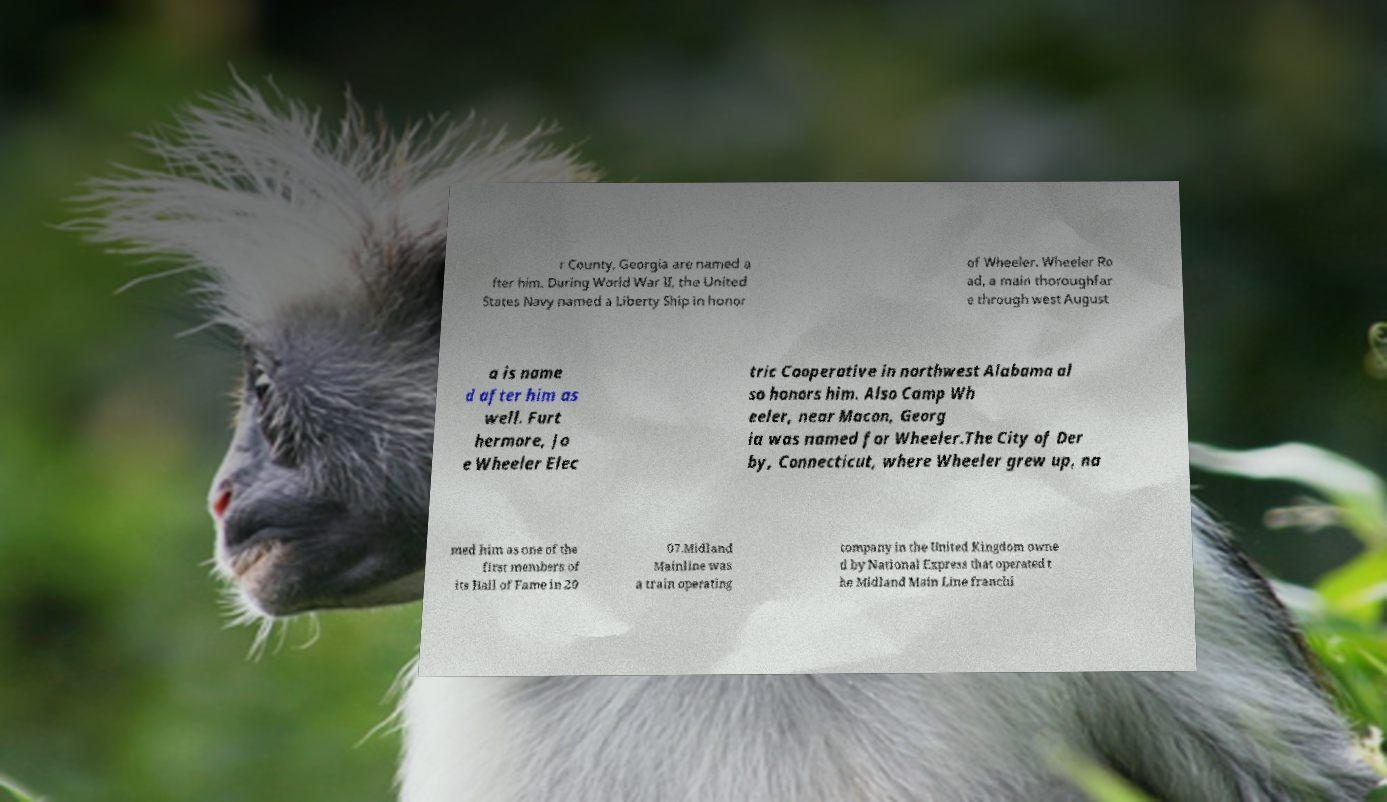Could you assist in decoding the text presented in this image and type it out clearly? r County, Georgia are named a fter him. During World War II, the United States Navy named a Liberty Ship in honor of Wheeler. Wheeler Ro ad, a main thoroughfar e through west August a is name d after him as well. Furt hermore, Jo e Wheeler Elec tric Cooperative in northwest Alabama al so honors him. Also Camp Wh eeler, near Macon, Georg ia was named for Wheeler.The City of Der by, Connecticut, where Wheeler grew up, na med him as one of the first members of its Hall of Fame in 20 07.Midland Mainline was a train operating company in the United Kingdom owne d by National Express that operated t he Midland Main Line franchi 